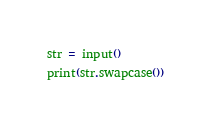Convert code to text. <code><loc_0><loc_0><loc_500><loc_500><_Python_>str = input()
print(str.swapcase())
</code> 